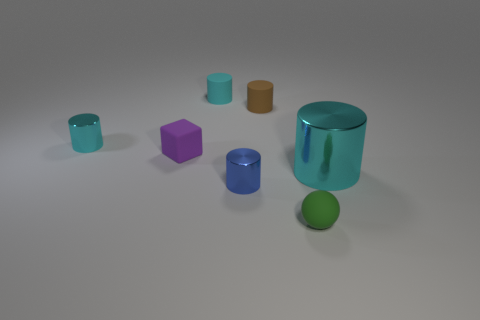Imagine this is a still from an animation. What could be happening next? In the next moment, we might see the spherical rubber object begin to bounce towards the camera, causing a chain reaction as it collides with the cylinders. The cylinders might topple or roll away, creating a dynamic and playful sequence. Alternatively, the larger cyan cylinder could rotate, revealing an opening that starts an intriguing plot twist.  If these objects represented characters in a story, what personality traits might they have? The larger cyan cylinder could be a confident and strong character due to its size and striking color. The purple cube might be more mysterious and intellectual, while the brown cylinder appears grounded and reliable. The green sphere, with its vibrant color and round shape, could represent a lively and energetic character. The remaining cylinders and cube might be youthful sidekicks or companions, each bringing their own unique traits to create a diverse cast. 